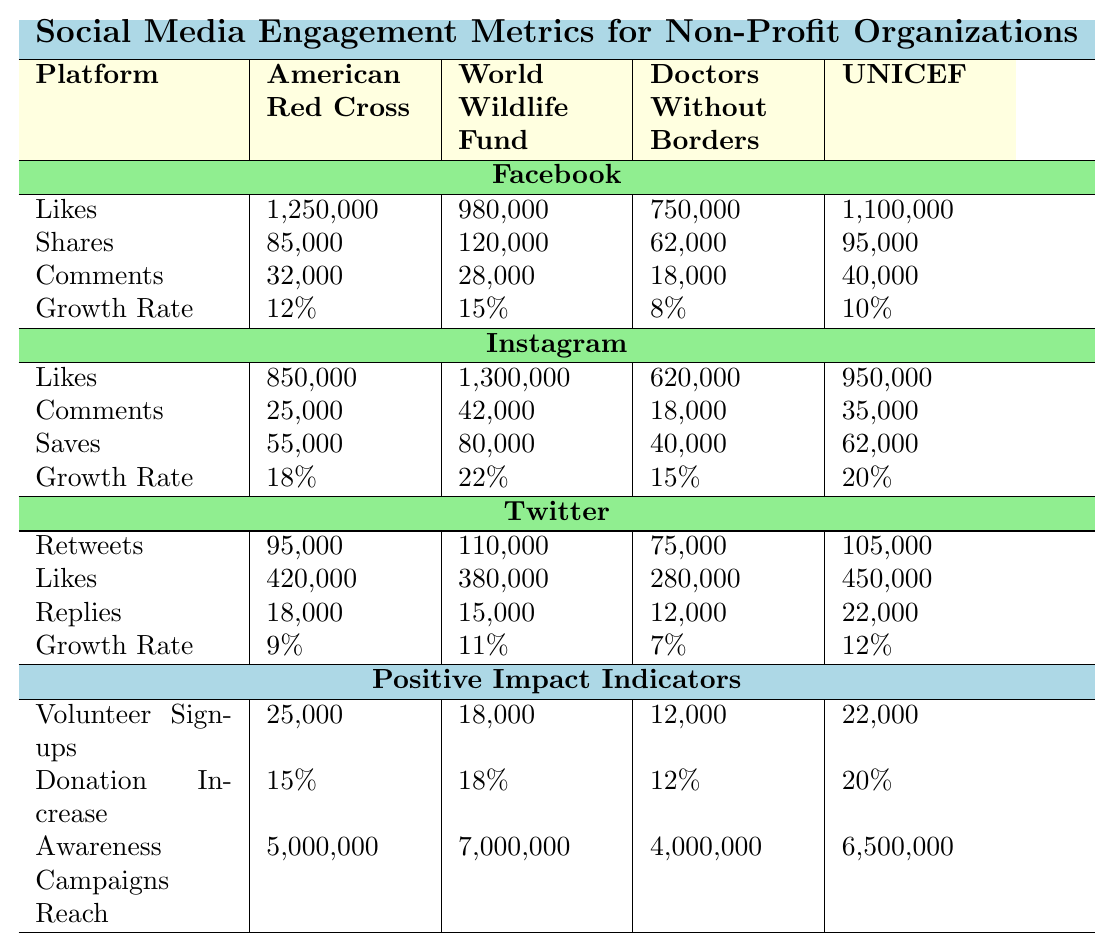What is the highest number of likes for a non-profit organization on Facebook? Referring to the Facebook section of the table, the highest number of likes is listed under American Red Cross with 1,250,000 likes.
Answer: 1,250,000 Which organization had the highest growth rate on Instagram? In the Instagram section, World Wildlife Fund has the highest growth rate at 22%.
Answer: 22% What is the total number of comments received by Doctors Without Borders across all platforms? From the table, the number of comments on Facebook is 18,000, on Instagram is 18,000, and on Twitter is 12,000. Adding these gives 18,000 + 18,000 + 12,000 = 48,000.
Answer: 48,000 Did the American Red Cross have more volunteer sign-ups than the World Wildlife Fund? The table shows that American Red Cross had 25,000 volunteer sign-ups while World Wildlife Fund had 18,000. Since 25,000 is greater than 18,000, the answer is yes.
Answer: Yes What is the average increase in donations for all four organizations? The donation increases are 15%, 18%, 12%, and 20%. The sum is 15 + 18 + 12 + 20 = 65. Dividing by 4 gives 65/4 = 16.25%.
Answer: 16.25% How many more likes did the World Wildlife Fund receive on Instagram compared to Facebook? On Instagram, World Wildlife Fund received 1,300,000 likes and on Facebook, it received 980,000 likes. The difference is 1,300,000 - 980,000 = 320,000 likes more.
Answer: 320,000 What percentage of the total awareness campaigns reach does the American Red Cross achieve compared to others? The total reach sums to 5,000,000 (American Red Cross) + 7,000,000 (World Wildlife Fund) + 4,000,000 (Doctors Without Borders) + 6,500,000 (UNICEF) = 22,500,000. The percentage for American Red Cross is (5,000,000 / 22,500,000) * 100 = 22.22%.
Answer: 22.22% Which platform showed the highest number of shares for the American Red Cross? The table indicates that for American Red Cross, the highest number of shares occurs on Facebook with 85,000 shares.
Answer: Facebook What is the total number of retweets received by all organizations on Twitter? Referring to the Twitter section, the total retweets are 95,000 (American Red Cross) + 110,000 (World Wildlife Fund) + 75,000 (Doctors Without Borders) + 105,000 (UNICEF) = 385,000 retweets.
Answer: 385,000 Is the total reach for UNICEF's awareness campaigns higher than that of the American Red Cross? The table shows UNICEF has a reach of 6,500,000 while American Red Cross has 5,000,000. Since 6,500,000 is greater than 5,000,000, the answer is yes.
Answer: Yes 